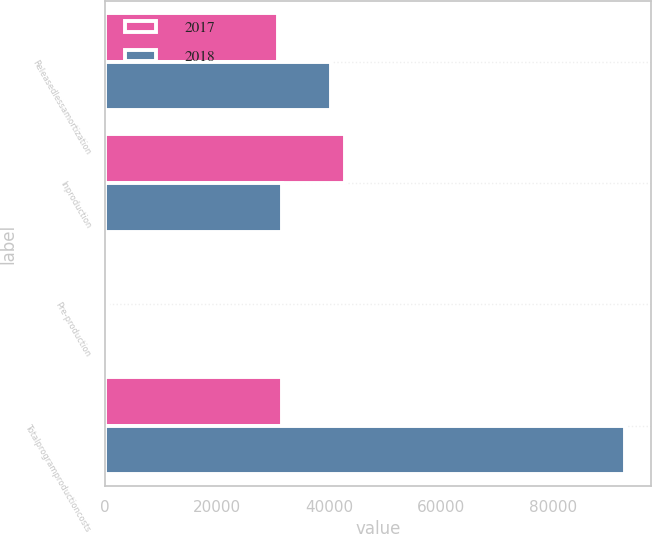Convert chart to OTSL. <chart><loc_0><loc_0><loc_500><loc_500><stacked_bar_chart><ecel><fcel>Releasedlessamortization<fcel>Inproduction<fcel>Pre-production<fcel>Totalprogramproductioncosts<nl><fcel>2017<fcel>30800<fcel>42768<fcel>489<fcel>31596<nl><fcel>2018<fcel>40386<fcel>31596<fcel>326<fcel>92861<nl></chart> 